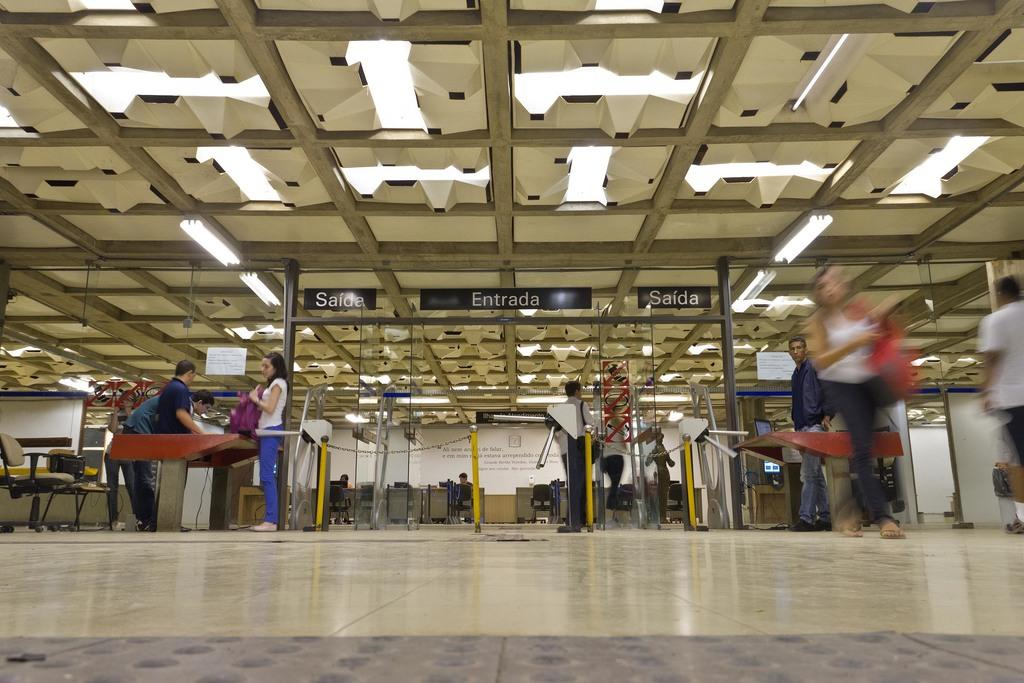What are the people in the image doing? The people in the image are standing on the floor. What can be seen in the background of the image? There are tables and chairs in the background of the image. What is located in the front of the image? There is a poster in the front of the image. What type of substance is being spread by the people in the image? There is no substance being spread by the people in the image; they are simply standing on the floor. 